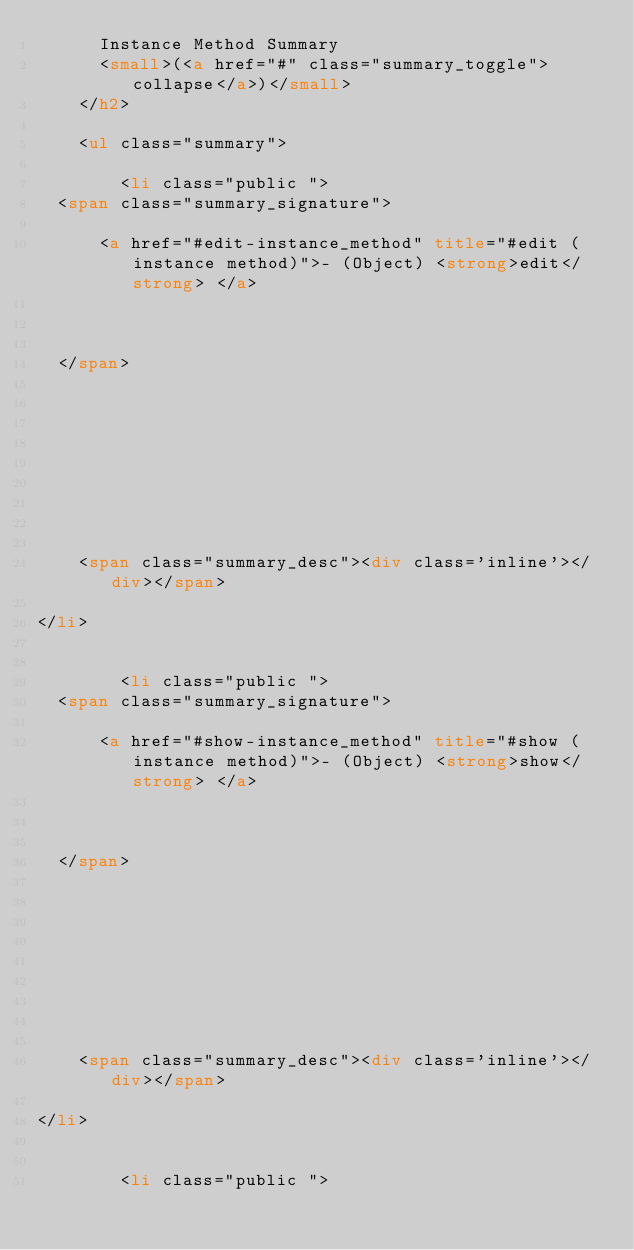<code> <loc_0><loc_0><loc_500><loc_500><_HTML_>      Instance Method Summary
      <small>(<a href="#" class="summary_toggle">collapse</a>)</small>
    </h2>

    <ul class="summary">
      
        <li class="public ">
  <span class="summary_signature">
    
      <a href="#edit-instance_method" title="#edit (instance method)">- (Object) <strong>edit</strong> </a>
    

    
  </span>
  
  
  
  
  
  
  

  
    <span class="summary_desc"><div class='inline'></div></span>
  
</li>

      
        <li class="public ">
  <span class="summary_signature">
    
      <a href="#show-instance_method" title="#show (instance method)">- (Object) <strong>show</strong> </a>
    

    
  </span>
  
  
  
  
  
  
  

  
    <span class="summary_desc"><div class='inline'></div></span>
  
</li>

      
        <li class="public "></code> 